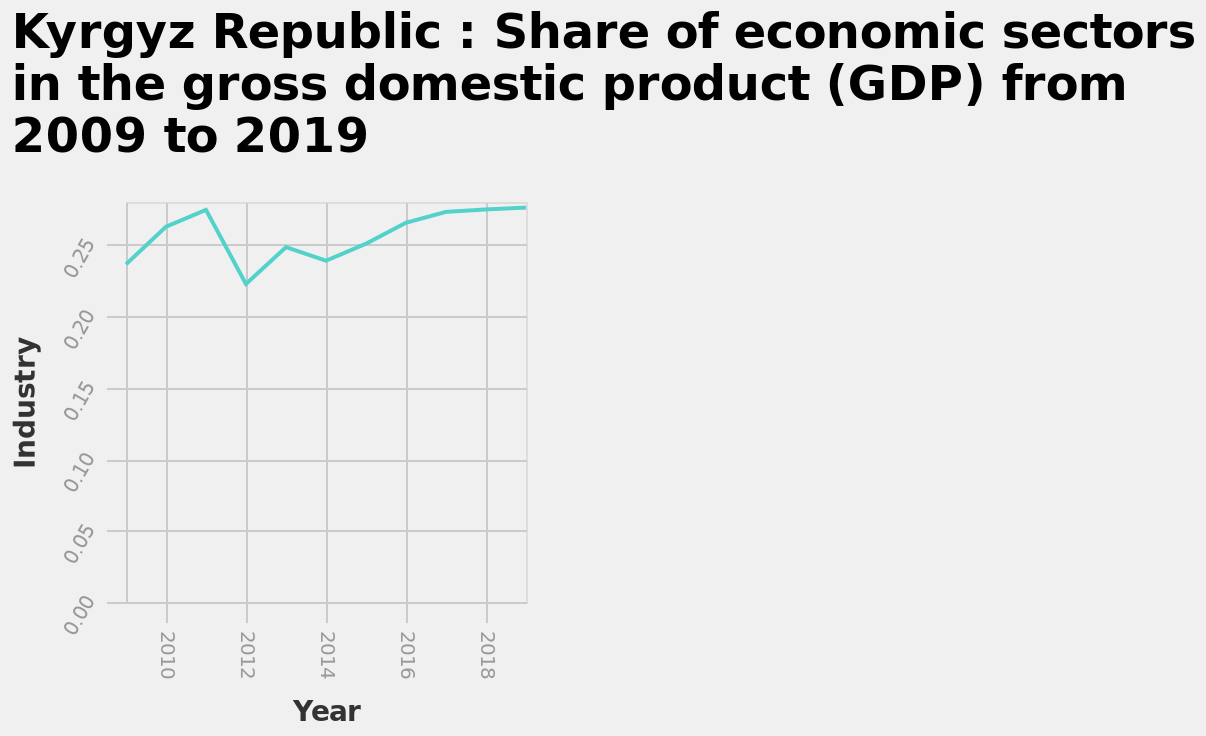<image>
What was the share of industry in GDP in 2012?  The share of industry in GDP was 0.225% in 2012. please summary the statistics and relations of the chart Industry has historically had a growing share of GDP until 2011 when it peaked at 0.25%. Since then, there was a steep drop in share to 0.225% in 2012 and then steady growth up to almost 0.30% in 2020. Was the share of industry in GDP 0.225% in 2019? No. The share of industry in GDP was 0.225% in 2012. 